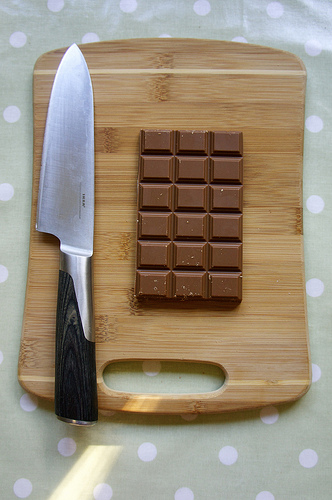<image>
Is there a knife on the table? Yes. Looking at the image, I can see the knife is positioned on top of the table, with the table providing support. 